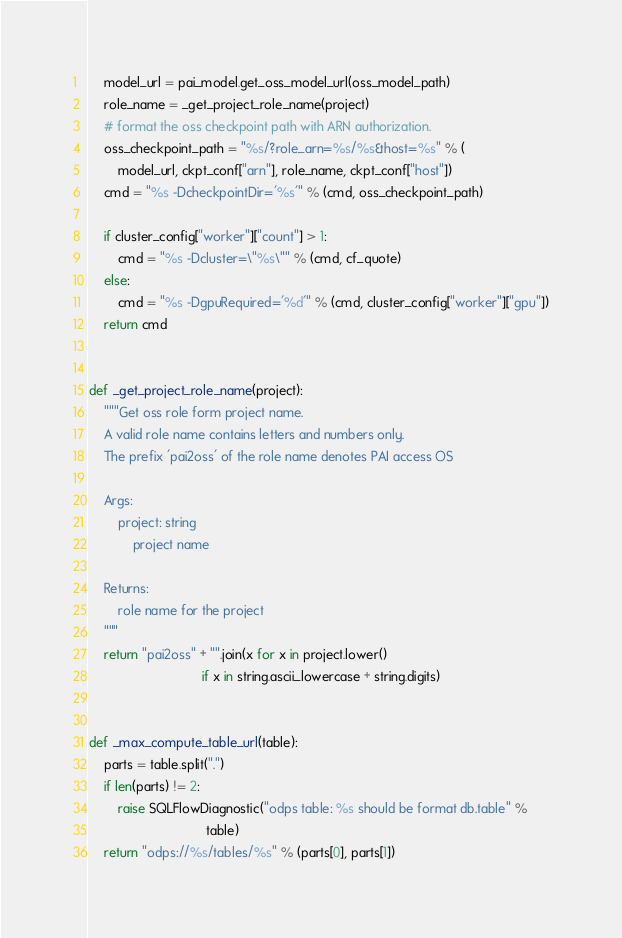Convert code to text. <code><loc_0><loc_0><loc_500><loc_500><_Python_>    model_url = pai_model.get_oss_model_url(oss_model_path)
    role_name = _get_project_role_name(project)
    # format the oss checkpoint path with ARN authorization.
    oss_checkpoint_path = "%s/?role_arn=%s/%s&host=%s" % (
        model_url, ckpt_conf["arn"], role_name, ckpt_conf["host"])
    cmd = "%s -DcheckpointDir='%s'" % (cmd, oss_checkpoint_path)

    if cluster_config["worker"]["count"] > 1:
        cmd = "%s -Dcluster=\"%s\"" % (cmd, cf_quote)
    else:
        cmd = "%s -DgpuRequired='%d'" % (cmd, cluster_config["worker"]["gpu"])
    return cmd


def _get_project_role_name(project):
    """Get oss role form project name.
    A valid role name contains letters and numbers only.
    The prefix 'pai2oss' of the role name denotes PAI access OS

    Args:
        project: string
            project name

    Returns:
        role name for the project
    """
    return "pai2oss" + "".join(x for x in project.lower()
                               if x in string.ascii_lowercase + string.digits)


def _max_compute_table_url(table):
    parts = table.split(".")
    if len(parts) != 2:
        raise SQLFlowDiagnostic("odps table: %s should be format db.table" %
                                table)
    return "odps://%s/tables/%s" % (parts[0], parts[1])
</code> 